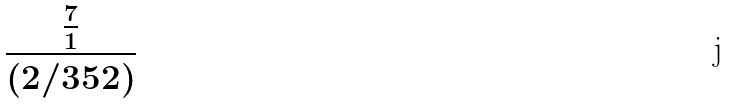Convert formula to latex. <formula><loc_0><loc_0><loc_500><loc_500>\frac { \frac { 7 } { 1 } } { ( 2 / 3 5 2 ) }</formula> 